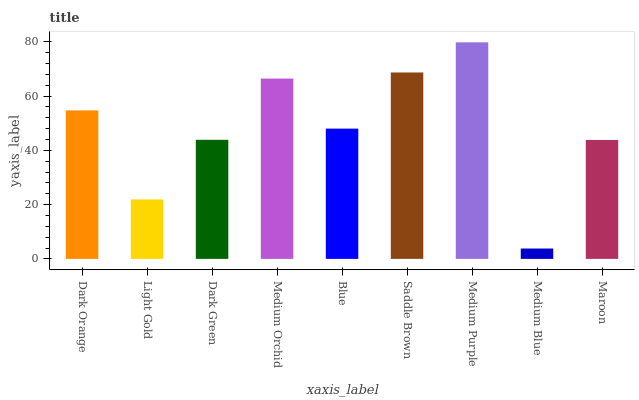Is Medium Blue the minimum?
Answer yes or no. Yes. Is Medium Purple the maximum?
Answer yes or no. Yes. Is Light Gold the minimum?
Answer yes or no. No. Is Light Gold the maximum?
Answer yes or no. No. Is Dark Orange greater than Light Gold?
Answer yes or no. Yes. Is Light Gold less than Dark Orange?
Answer yes or no. Yes. Is Light Gold greater than Dark Orange?
Answer yes or no. No. Is Dark Orange less than Light Gold?
Answer yes or no. No. Is Blue the high median?
Answer yes or no. Yes. Is Blue the low median?
Answer yes or no. Yes. Is Medium Purple the high median?
Answer yes or no. No. Is Light Gold the low median?
Answer yes or no. No. 